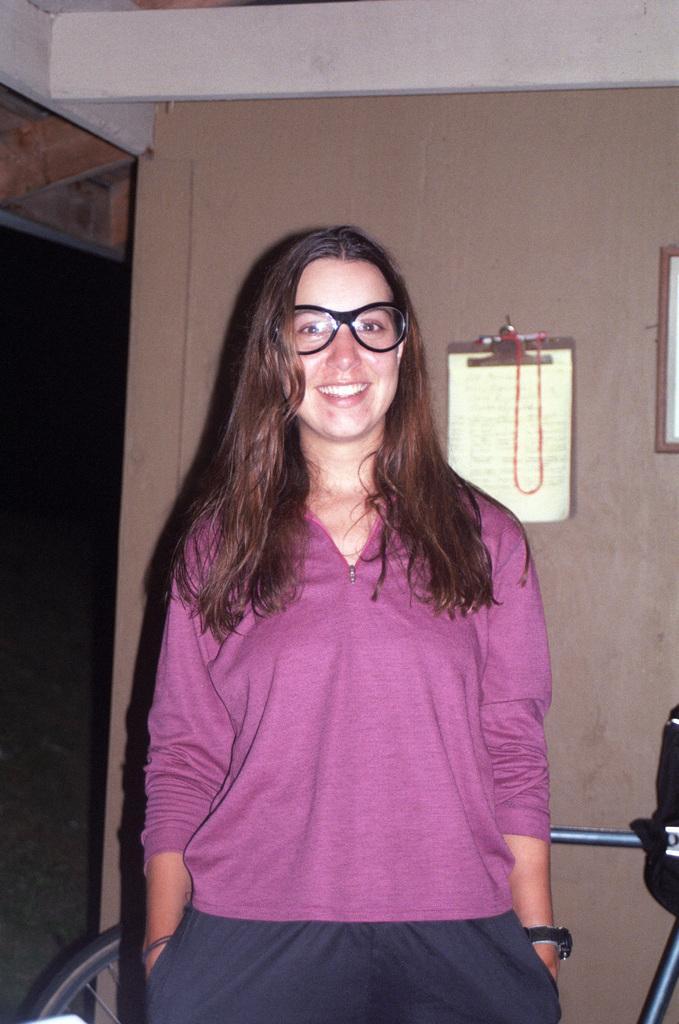How would you summarize this image in a sentence or two? I this picture i can see a woman, She wore spectacles and a smile on her face and I can see couple of examination pads with papers on the wall and a bicycle on the back. 